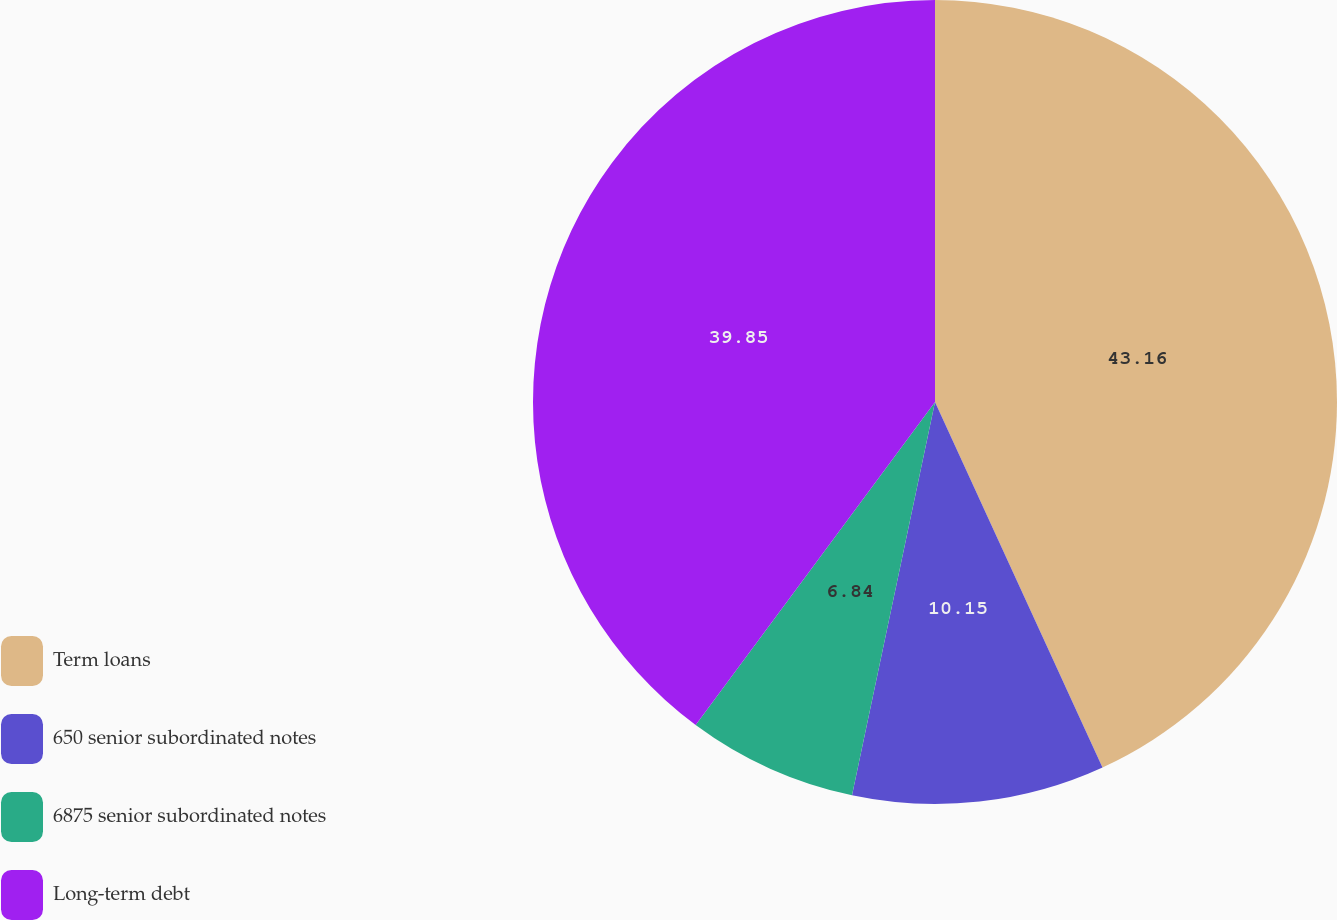Convert chart. <chart><loc_0><loc_0><loc_500><loc_500><pie_chart><fcel>Term loans<fcel>650 senior subordinated notes<fcel>6875 senior subordinated notes<fcel>Long-term debt<nl><fcel>43.16%<fcel>10.15%<fcel>6.84%<fcel>39.85%<nl></chart> 